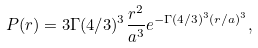<formula> <loc_0><loc_0><loc_500><loc_500>P ( r ) = 3 \Gamma ( 4 / 3 ) ^ { 3 } \frac { r ^ { 2 } } { a ^ { 3 } } e ^ { - \Gamma ( 4 / 3 ) ^ { 3 } ( r / a ) ^ { 3 } } ,</formula> 